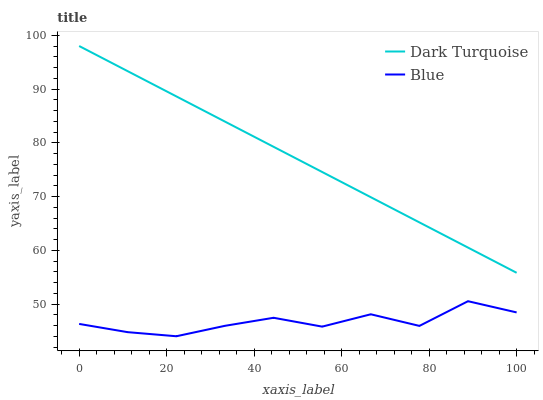Does Blue have the minimum area under the curve?
Answer yes or no. Yes. Does Dark Turquoise have the maximum area under the curve?
Answer yes or no. Yes. Does Dark Turquoise have the minimum area under the curve?
Answer yes or no. No. Is Dark Turquoise the smoothest?
Answer yes or no. Yes. Is Blue the roughest?
Answer yes or no. Yes. Is Dark Turquoise the roughest?
Answer yes or no. No. Does Dark Turquoise have the lowest value?
Answer yes or no. No. Does Dark Turquoise have the highest value?
Answer yes or no. Yes. Is Blue less than Dark Turquoise?
Answer yes or no. Yes. Is Dark Turquoise greater than Blue?
Answer yes or no. Yes. Does Blue intersect Dark Turquoise?
Answer yes or no. No. 